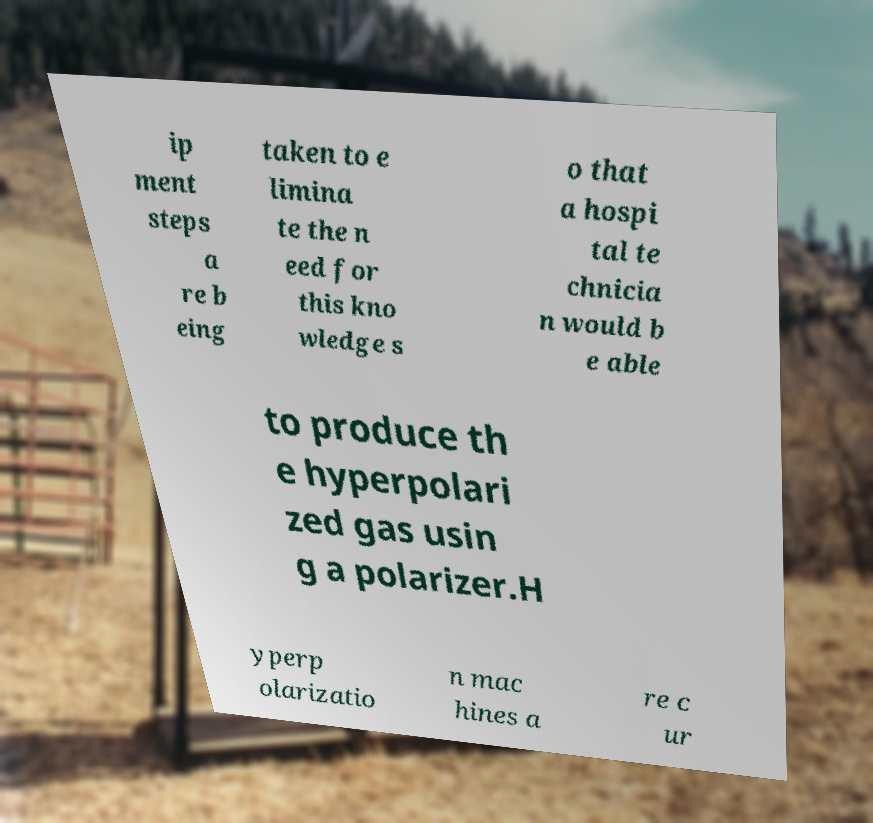Please read and relay the text visible in this image. What does it say? ip ment steps a re b eing taken to e limina te the n eed for this kno wledge s o that a hospi tal te chnicia n would b e able to produce th e hyperpolari zed gas usin g a polarizer.H yperp olarizatio n mac hines a re c ur 